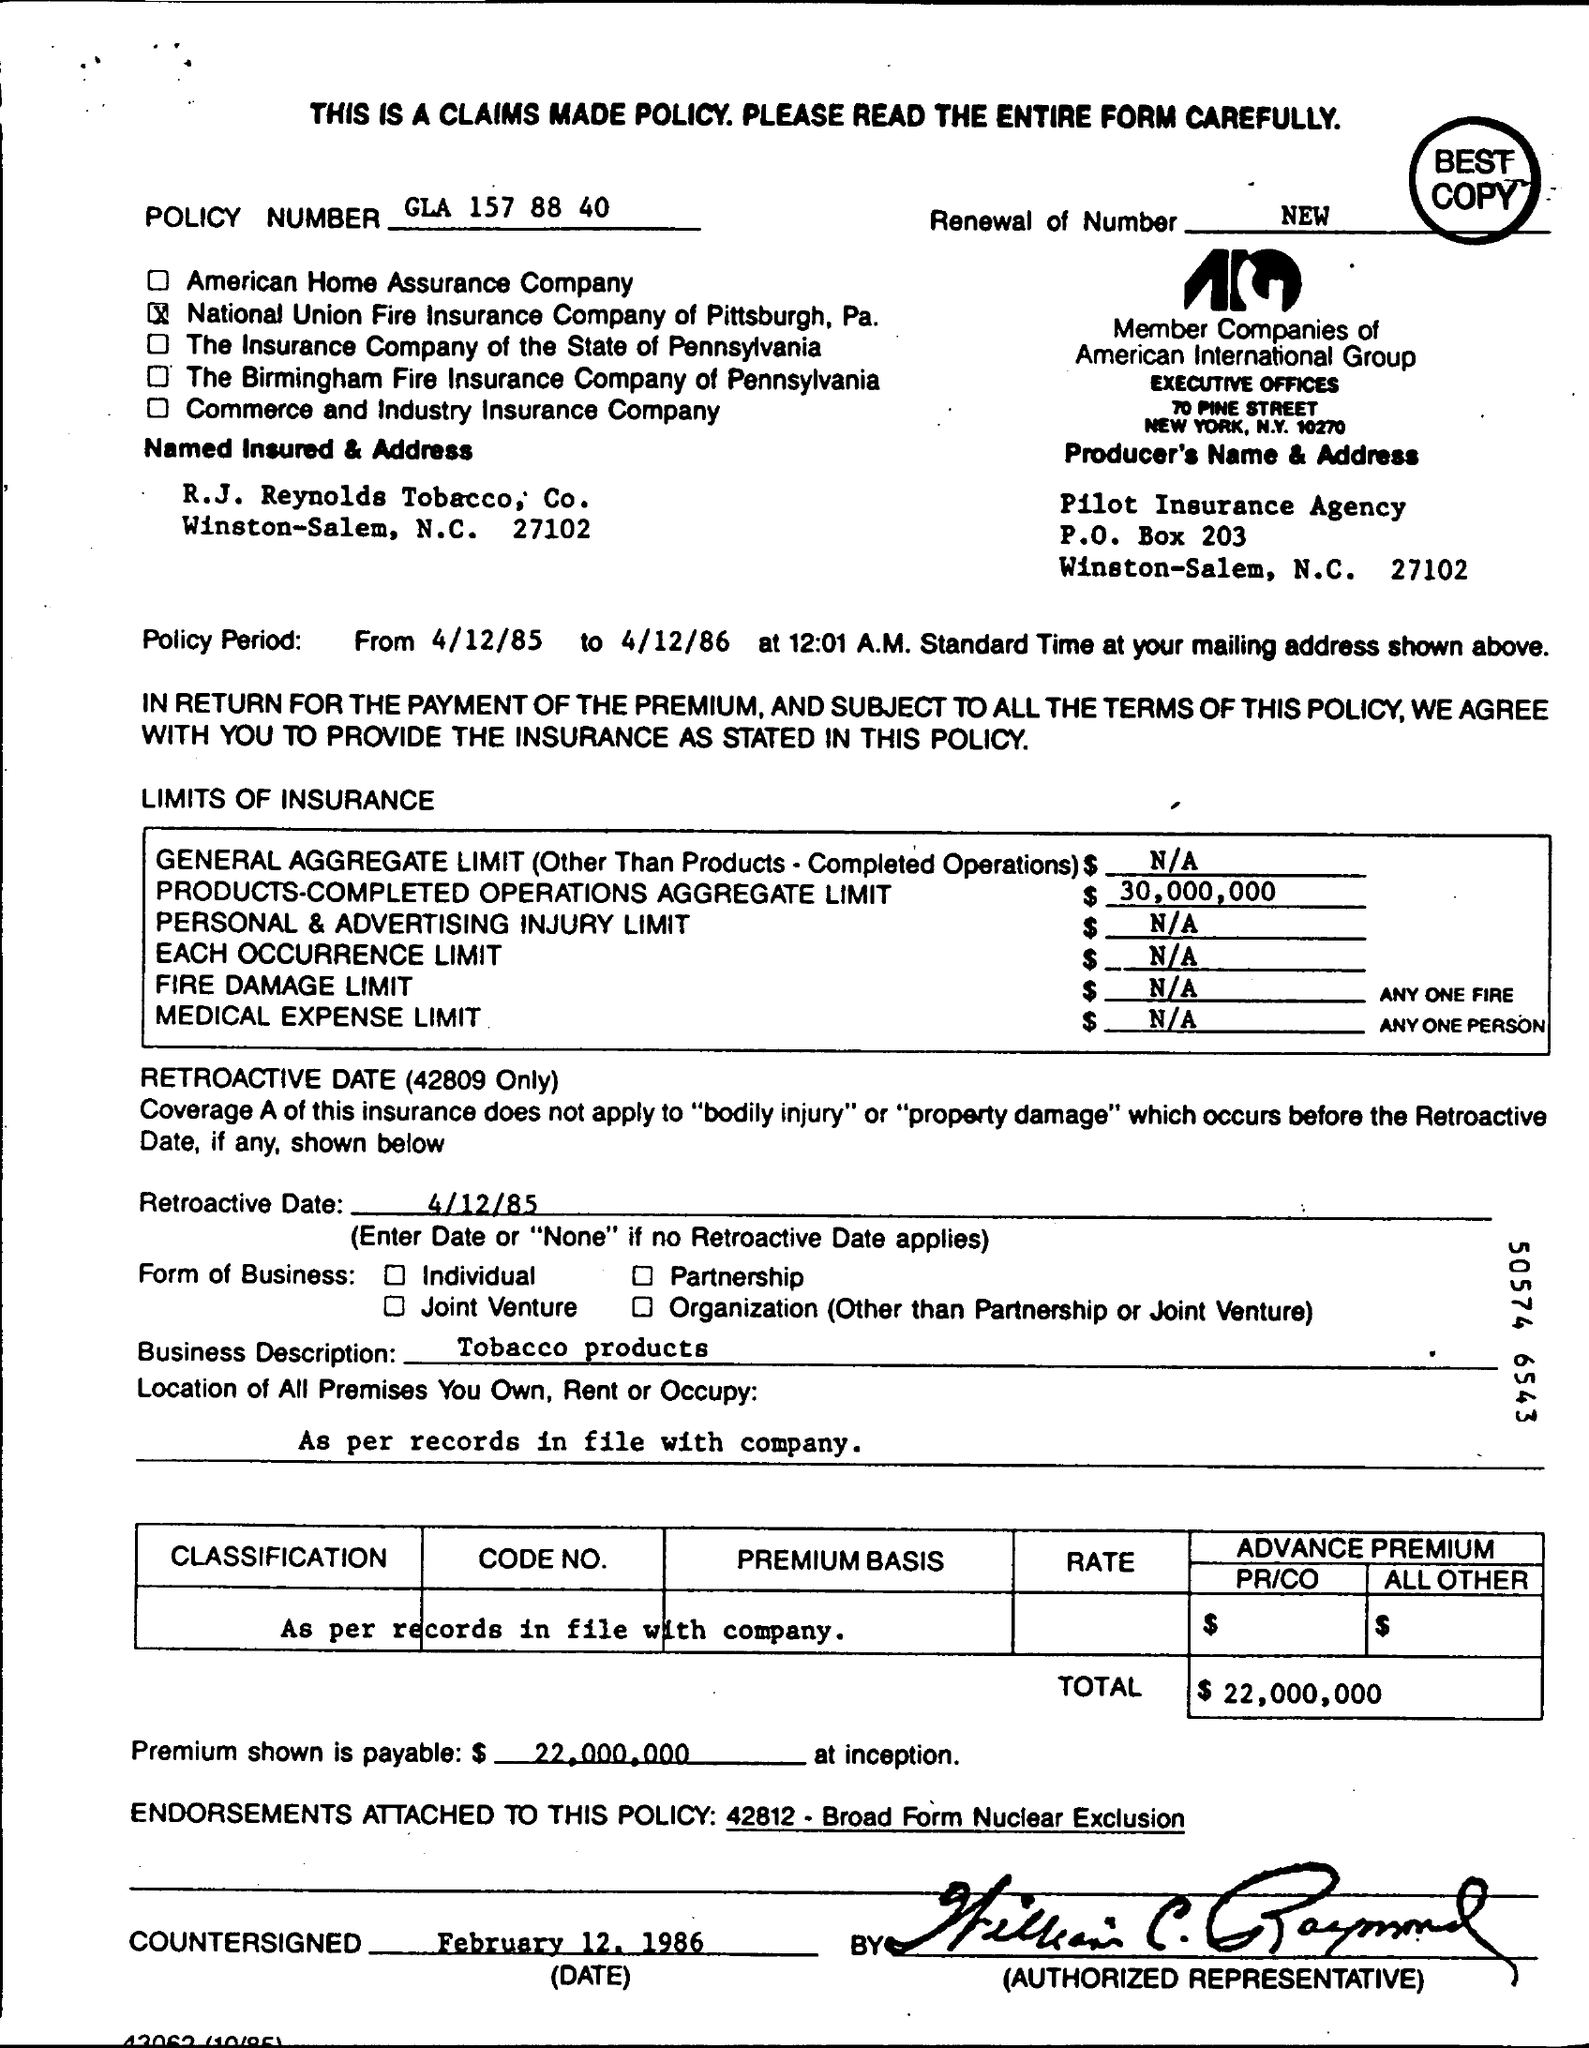Draw attention to some important aspects in this diagram. The R.J. Reynolds Tobacco Company is insured by this form. The countersigned date written on the policy is February 12, 1986. The policy has been produced by Pilot Insurance Agency. The policy number is GLA 157 88 40. The total cost of this bill is $22,000,000. 